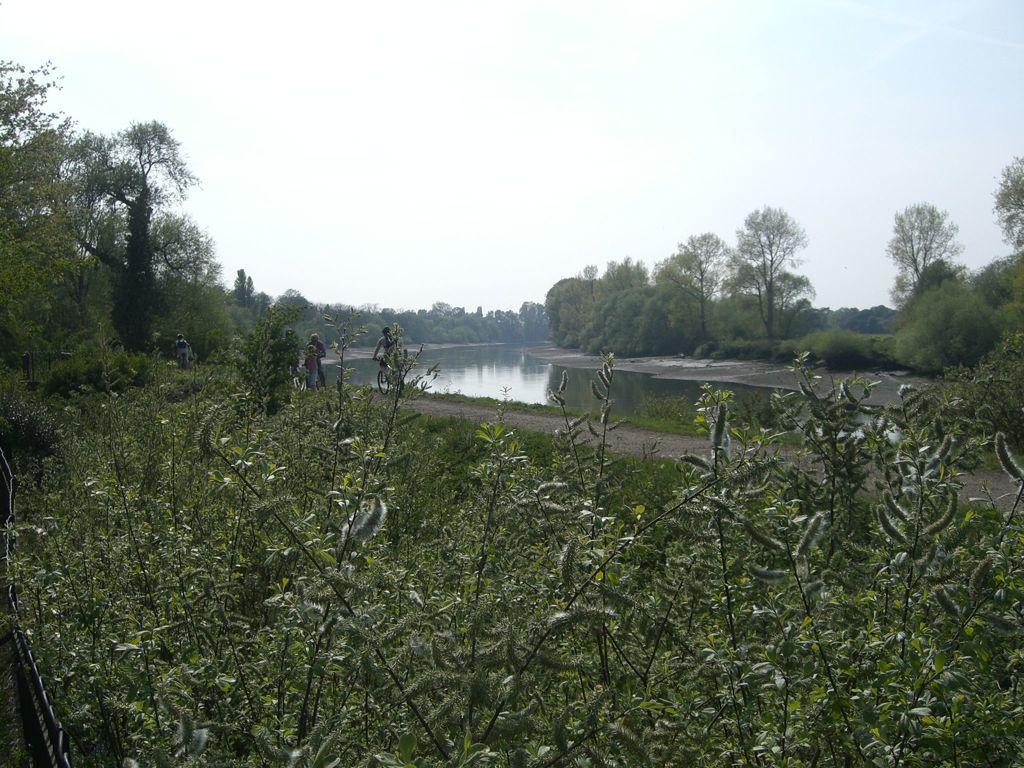Can you describe this image briefly? This image consists of many trees and plants. In the middle, there is water. At the top, there is sky. 